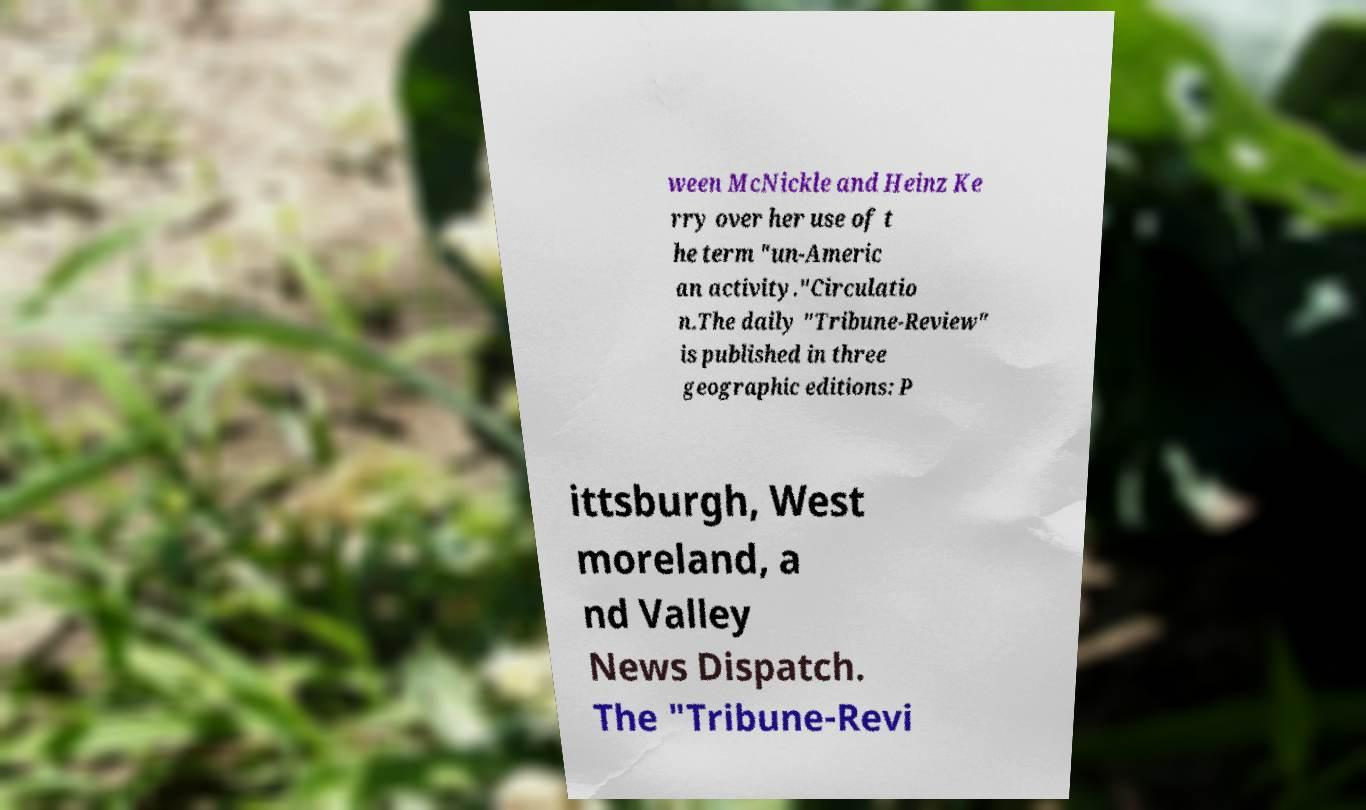Could you assist in decoding the text presented in this image and type it out clearly? ween McNickle and Heinz Ke rry over her use of t he term "un-Americ an activity."Circulatio n.The daily "Tribune-Review" is published in three geographic editions: P ittsburgh, West moreland, a nd Valley News Dispatch. The "Tribune-Revi 